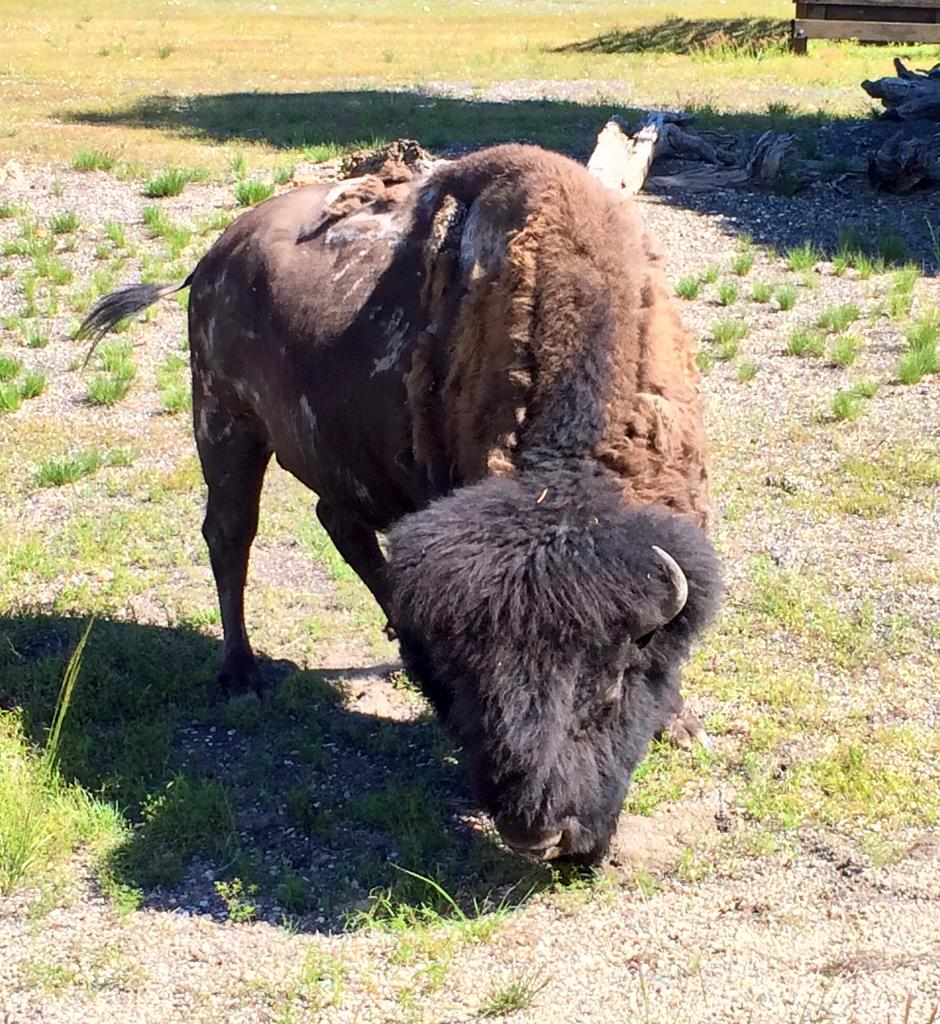What type of terrain is visible in the image? There is an open grass ground in the image. What can be observed on the grass ground? Shadows are visible on the grass ground. What color is the yark in the image? The yark in the image is brown-colored. What type of letter is being delivered to the town in the image? There is no town or letter present in the image; it features an open grass ground with shadows and a brown-colored yark. 